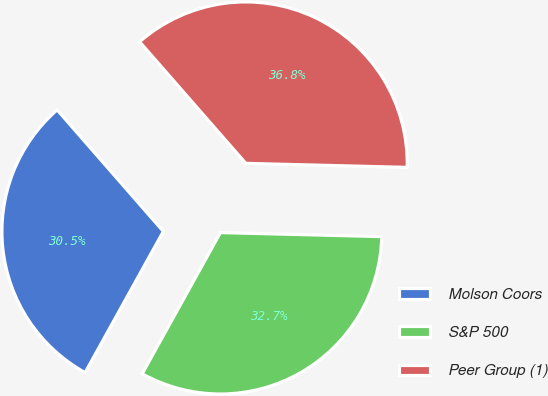Convert chart to OTSL. <chart><loc_0><loc_0><loc_500><loc_500><pie_chart><fcel>Molson Coors<fcel>S&P 500<fcel>Peer Group (1)<nl><fcel>30.52%<fcel>32.66%<fcel>36.83%<nl></chart> 